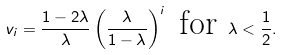Convert formula to latex. <formula><loc_0><loc_0><loc_500><loc_500>v _ { i } = \frac { 1 - 2 \lambda } { \lambda } \left ( \frac { \lambda } { 1 - \lambda } \right ) ^ { i } \text { for } \lambda < \frac { 1 } { 2 } .</formula> 